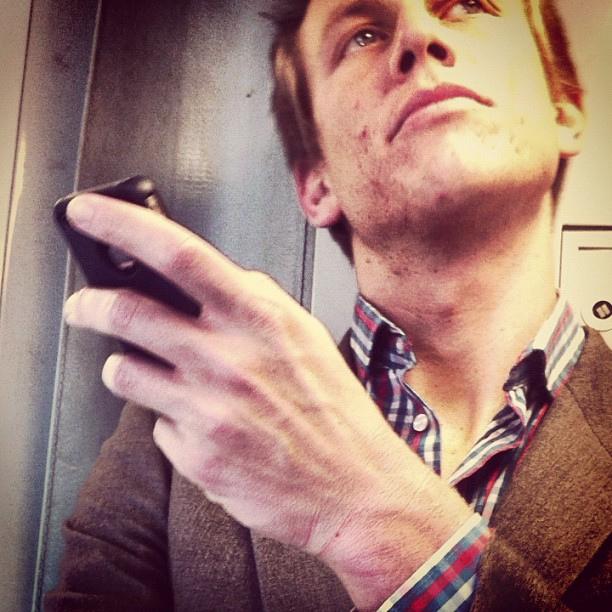Does this man have acne?
Concise answer only. Yes. What is the man holding in his hand?
Keep it brief. Cell phone. Does this man have long hair?
Write a very short answer. No. 